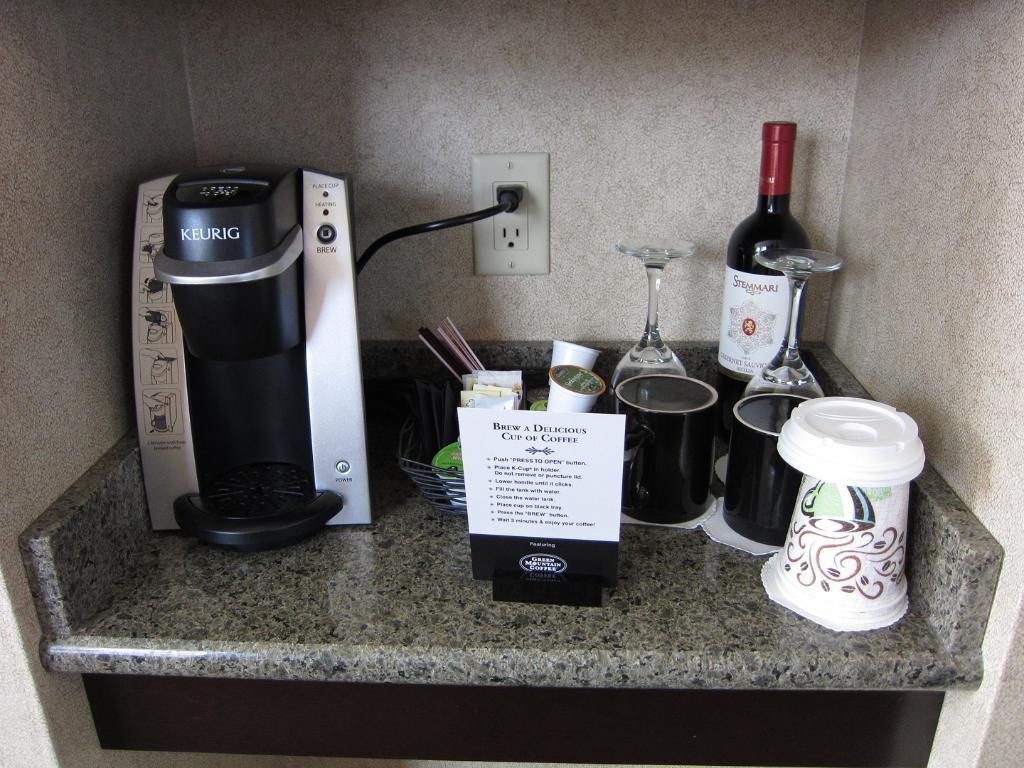<image>
Offer a succinct explanation of the picture presented. Coffee and wine bar with a note saying "Brew a Delicious Cup of Coffee" with the instructions to do so. 